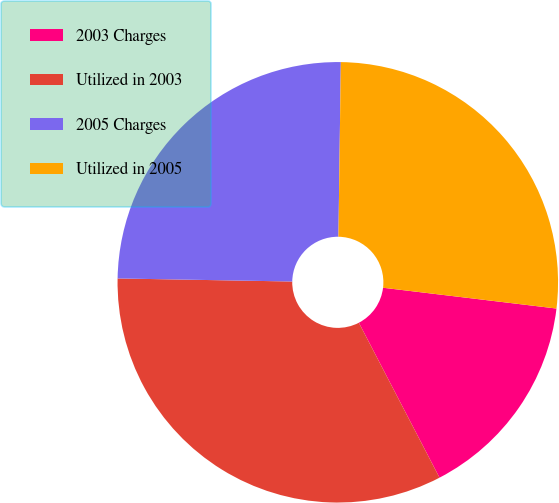Convert chart. <chart><loc_0><loc_0><loc_500><loc_500><pie_chart><fcel>2003 Charges<fcel>Utilized in 2003<fcel>2005 Charges<fcel>Utilized in 2005<nl><fcel>15.46%<fcel>32.92%<fcel>24.94%<fcel>26.68%<nl></chart> 